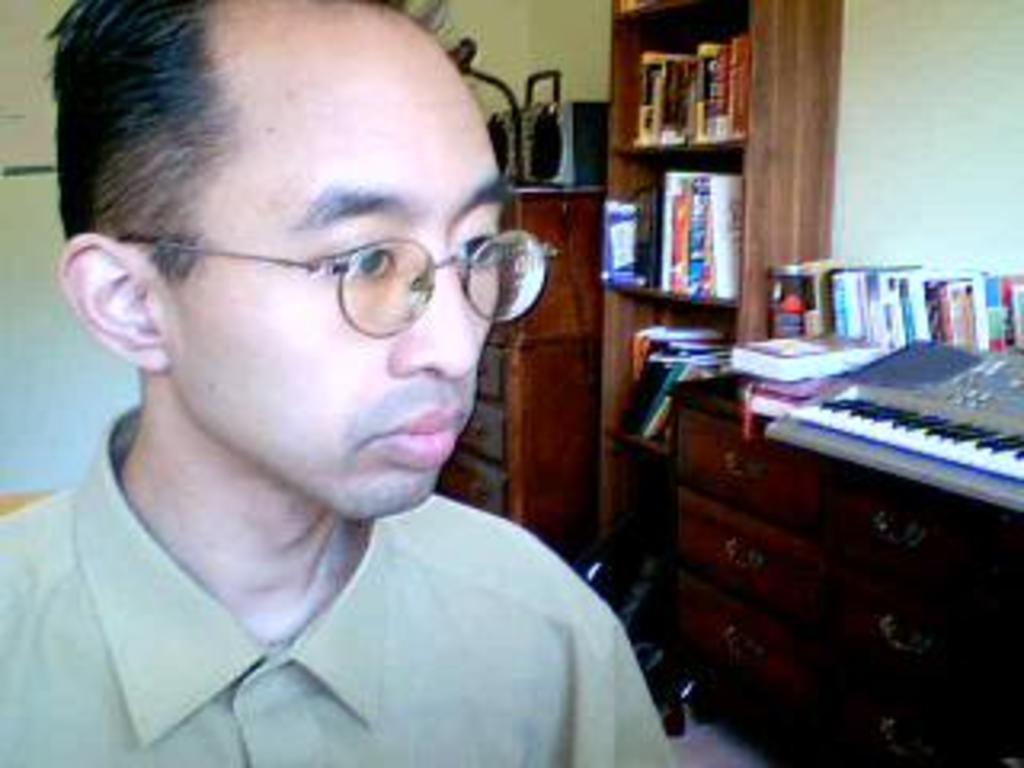Please provide a concise description of this image. In this image we can see a man. In the background we books and cupboards. 